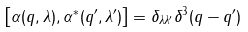<formula> <loc_0><loc_0><loc_500><loc_500>\left [ \alpha ( q , \lambda ) , \alpha ^ { * } ( q ^ { \prime } , \lambda ^ { \prime } ) \right ] = \delta _ { \lambda \lambda ^ { \prime } } \delta ^ { 3 } ( q - q ^ { \prime } )</formula> 